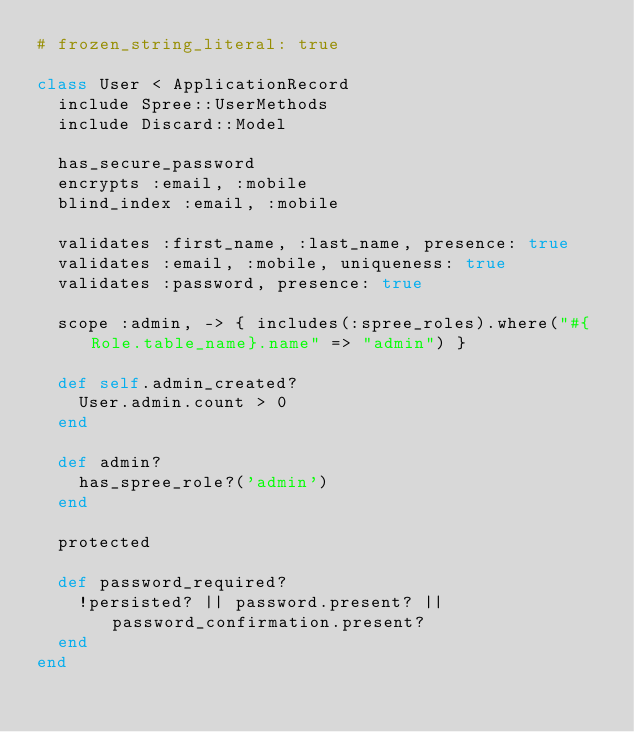<code> <loc_0><loc_0><loc_500><loc_500><_Ruby_># frozen_string_literal: true

class User < ApplicationRecord
  include Spree::UserMethods
  include Discard::Model

  has_secure_password
  encrypts :email, :mobile
  blind_index :email, :mobile

  validates :first_name, :last_name, presence: true
  validates :email, :mobile, uniqueness: true
  validates :password, presence: true

  scope :admin, -> { includes(:spree_roles).where("#{Role.table_name}.name" => "admin") }

  def self.admin_created?
    User.admin.count > 0
  end

  def admin?
    has_spree_role?('admin')
  end

  protected

  def password_required?
    !persisted? || password.present? || password_confirmation.present?
  end
end
</code> 